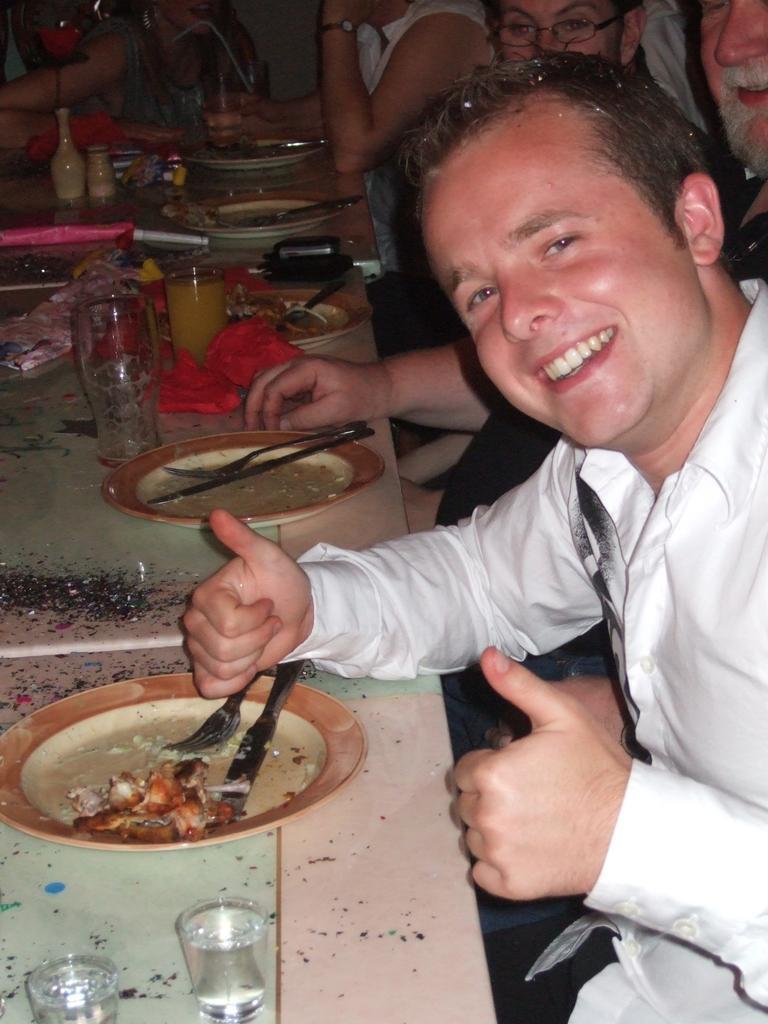Please provide a concise description of this image. On the right side of the image we can see persons sitting at the table. On the left side of the image we can see plates, knife, forks, glasses, glass tumblers, mobile phones placed on the table. 